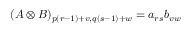Convert formula to latex. <formula><loc_0><loc_0><loc_500><loc_500>( A \otimes B ) _ { p ( r - 1 ) + v , q ( s - 1 ) + w } = a _ { r s } b _ { v w }</formula> 